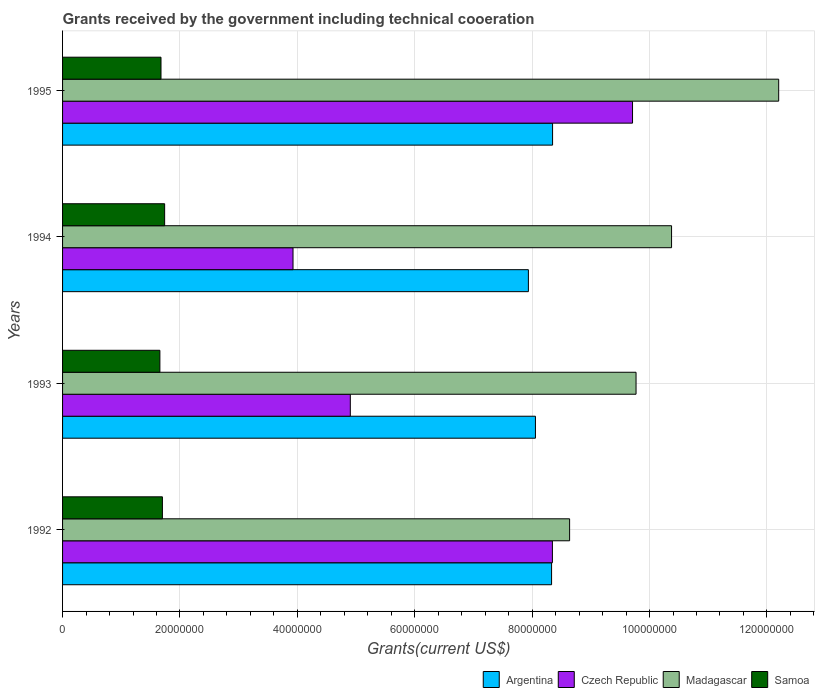How many different coloured bars are there?
Make the answer very short. 4. What is the total grants received by the government in Argentina in 1992?
Your answer should be very brief. 8.33e+07. Across all years, what is the maximum total grants received by the government in Samoa?
Provide a short and direct response. 1.74e+07. Across all years, what is the minimum total grants received by the government in Czech Republic?
Your answer should be compact. 3.93e+07. In which year was the total grants received by the government in Argentina maximum?
Keep it short and to the point. 1995. In which year was the total grants received by the government in Argentina minimum?
Offer a very short reply. 1994. What is the total total grants received by the government in Czech Republic in the graph?
Your answer should be very brief. 2.69e+08. What is the difference between the total grants received by the government in Czech Republic in 1994 and that in 1995?
Give a very brief answer. -5.78e+07. What is the difference between the total grants received by the government in Madagascar in 1993 and the total grants received by the government in Argentina in 1995?
Your answer should be compact. 1.42e+07. What is the average total grants received by the government in Czech Republic per year?
Provide a succinct answer. 6.72e+07. In the year 1993, what is the difference between the total grants received by the government in Czech Republic and total grants received by the government in Samoa?
Your answer should be very brief. 3.24e+07. In how many years, is the total grants received by the government in Argentina greater than 12000000 US$?
Your response must be concise. 4. What is the ratio of the total grants received by the government in Madagascar in 1993 to that in 1995?
Give a very brief answer. 0.8. Is the total grants received by the government in Argentina in 1994 less than that in 1995?
Provide a succinct answer. Yes. What is the difference between the highest and the second highest total grants received by the government in Czech Republic?
Offer a very short reply. 1.36e+07. What is the difference between the highest and the lowest total grants received by the government in Samoa?
Provide a succinct answer. 8.10e+05. What does the 1st bar from the top in 1995 represents?
Make the answer very short. Samoa. What does the 1st bar from the bottom in 1993 represents?
Your response must be concise. Argentina. Is it the case that in every year, the sum of the total grants received by the government in Madagascar and total grants received by the government in Czech Republic is greater than the total grants received by the government in Samoa?
Provide a succinct answer. Yes. How many bars are there?
Provide a short and direct response. 16. How many years are there in the graph?
Your answer should be compact. 4. What is the difference between two consecutive major ticks on the X-axis?
Offer a very short reply. 2.00e+07. How are the legend labels stacked?
Offer a very short reply. Horizontal. What is the title of the graph?
Offer a terse response. Grants received by the government including technical cooeration. What is the label or title of the X-axis?
Offer a terse response. Grants(current US$). What is the label or title of the Y-axis?
Keep it short and to the point. Years. What is the Grants(current US$) in Argentina in 1992?
Offer a terse response. 8.33e+07. What is the Grants(current US$) of Czech Republic in 1992?
Ensure brevity in your answer.  8.34e+07. What is the Grants(current US$) of Madagascar in 1992?
Offer a very short reply. 8.64e+07. What is the Grants(current US$) of Samoa in 1992?
Keep it short and to the point. 1.70e+07. What is the Grants(current US$) of Argentina in 1993?
Offer a very short reply. 8.06e+07. What is the Grants(current US$) of Czech Republic in 1993?
Your answer should be very brief. 4.90e+07. What is the Grants(current US$) of Madagascar in 1993?
Ensure brevity in your answer.  9.77e+07. What is the Grants(current US$) in Samoa in 1993?
Your response must be concise. 1.66e+07. What is the Grants(current US$) of Argentina in 1994?
Give a very brief answer. 7.94e+07. What is the Grants(current US$) of Czech Republic in 1994?
Your response must be concise. 3.93e+07. What is the Grants(current US$) of Madagascar in 1994?
Ensure brevity in your answer.  1.04e+08. What is the Grants(current US$) of Samoa in 1994?
Ensure brevity in your answer.  1.74e+07. What is the Grants(current US$) of Argentina in 1995?
Offer a very short reply. 8.35e+07. What is the Grants(current US$) of Czech Republic in 1995?
Make the answer very short. 9.71e+07. What is the Grants(current US$) in Madagascar in 1995?
Keep it short and to the point. 1.22e+08. What is the Grants(current US$) of Samoa in 1995?
Ensure brevity in your answer.  1.68e+07. Across all years, what is the maximum Grants(current US$) in Argentina?
Offer a very short reply. 8.35e+07. Across all years, what is the maximum Grants(current US$) in Czech Republic?
Your response must be concise. 9.71e+07. Across all years, what is the maximum Grants(current US$) of Madagascar?
Your response must be concise. 1.22e+08. Across all years, what is the maximum Grants(current US$) in Samoa?
Ensure brevity in your answer.  1.74e+07. Across all years, what is the minimum Grants(current US$) in Argentina?
Ensure brevity in your answer.  7.94e+07. Across all years, what is the minimum Grants(current US$) in Czech Republic?
Offer a very short reply. 3.93e+07. Across all years, what is the minimum Grants(current US$) in Madagascar?
Offer a very short reply. 8.64e+07. Across all years, what is the minimum Grants(current US$) of Samoa?
Keep it short and to the point. 1.66e+07. What is the total Grants(current US$) in Argentina in the graph?
Your answer should be very brief. 3.27e+08. What is the total Grants(current US$) of Czech Republic in the graph?
Your answer should be compact. 2.69e+08. What is the total Grants(current US$) in Madagascar in the graph?
Offer a terse response. 4.10e+08. What is the total Grants(current US$) of Samoa in the graph?
Offer a very short reply. 6.78e+07. What is the difference between the Grants(current US$) of Argentina in 1992 and that in 1993?
Give a very brief answer. 2.75e+06. What is the difference between the Grants(current US$) of Czech Republic in 1992 and that in 1993?
Ensure brevity in your answer.  3.44e+07. What is the difference between the Grants(current US$) in Madagascar in 1992 and that in 1993?
Ensure brevity in your answer.  -1.13e+07. What is the difference between the Grants(current US$) in Argentina in 1992 and that in 1994?
Ensure brevity in your answer.  3.95e+06. What is the difference between the Grants(current US$) of Czech Republic in 1992 and that in 1994?
Ensure brevity in your answer.  4.42e+07. What is the difference between the Grants(current US$) of Madagascar in 1992 and that in 1994?
Provide a succinct answer. -1.74e+07. What is the difference between the Grants(current US$) of Samoa in 1992 and that in 1994?
Offer a very short reply. -3.80e+05. What is the difference between the Grants(current US$) of Czech Republic in 1992 and that in 1995?
Provide a succinct answer. -1.36e+07. What is the difference between the Grants(current US$) in Madagascar in 1992 and that in 1995?
Your response must be concise. -3.56e+07. What is the difference between the Grants(current US$) of Samoa in 1992 and that in 1995?
Offer a very short reply. 2.40e+05. What is the difference between the Grants(current US$) in Argentina in 1993 and that in 1994?
Make the answer very short. 1.20e+06. What is the difference between the Grants(current US$) of Czech Republic in 1993 and that in 1994?
Make the answer very short. 9.76e+06. What is the difference between the Grants(current US$) of Madagascar in 1993 and that in 1994?
Ensure brevity in your answer.  -6.05e+06. What is the difference between the Grants(current US$) of Samoa in 1993 and that in 1994?
Your response must be concise. -8.10e+05. What is the difference between the Grants(current US$) in Argentina in 1993 and that in 1995?
Give a very brief answer. -2.92e+06. What is the difference between the Grants(current US$) in Czech Republic in 1993 and that in 1995?
Offer a very short reply. -4.81e+07. What is the difference between the Grants(current US$) of Madagascar in 1993 and that in 1995?
Provide a short and direct response. -2.43e+07. What is the difference between the Grants(current US$) of Argentina in 1994 and that in 1995?
Your response must be concise. -4.12e+06. What is the difference between the Grants(current US$) in Czech Republic in 1994 and that in 1995?
Offer a very short reply. -5.78e+07. What is the difference between the Grants(current US$) of Madagascar in 1994 and that in 1995?
Keep it short and to the point. -1.82e+07. What is the difference between the Grants(current US$) of Samoa in 1994 and that in 1995?
Keep it short and to the point. 6.20e+05. What is the difference between the Grants(current US$) in Argentina in 1992 and the Grants(current US$) in Czech Republic in 1993?
Keep it short and to the point. 3.43e+07. What is the difference between the Grants(current US$) of Argentina in 1992 and the Grants(current US$) of Madagascar in 1993?
Offer a terse response. -1.44e+07. What is the difference between the Grants(current US$) in Argentina in 1992 and the Grants(current US$) in Samoa in 1993?
Your answer should be very brief. 6.67e+07. What is the difference between the Grants(current US$) in Czech Republic in 1992 and the Grants(current US$) in Madagascar in 1993?
Provide a short and direct response. -1.42e+07. What is the difference between the Grants(current US$) of Czech Republic in 1992 and the Grants(current US$) of Samoa in 1993?
Provide a succinct answer. 6.69e+07. What is the difference between the Grants(current US$) in Madagascar in 1992 and the Grants(current US$) in Samoa in 1993?
Offer a terse response. 6.98e+07. What is the difference between the Grants(current US$) in Argentina in 1992 and the Grants(current US$) in Czech Republic in 1994?
Provide a short and direct response. 4.40e+07. What is the difference between the Grants(current US$) of Argentina in 1992 and the Grants(current US$) of Madagascar in 1994?
Offer a terse response. -2.04e+07. What is the difference between the Grants(current US$) in Argentina in 1992 and the Grants(current US$) in Samoa in 1994?
Keep it short and to the point. 6.59e+07. What is the difference between the Grants(current US$) in Czech Republic in 1992 and the Grants(current US$) in Madagascar in 1994?
Provide a short and direct response. -2.03e+07. What is the difference between the Grants(current US$) of Czech Republic in 1992 and the Grants(current US$) of Samoa in 1994?
Provide a succinct answer. 6.61e+07. What is the difference between the Grants(current US$) in Madagascar in 1992 and the Grants(current US$) in Samoa in 1994?
Your response must be concise. 6.90e+07. What is the difference between the Grants(current US$) in Argentina in 1992 and the Grants(current US$) in Czech Republic in 1995?
Provide a succinct answer. -1.38e+07. What is the difference between the Grants(current US$) in Argentina in 1992 and the Grants(current US$) in Madagascar in 1995?
Make the answer very short. -3.87e+07. What is the difference between the Grants(current US$) of Argentina in 1992 and the Grants(current US$) of Samoa in 1995?
Your response must be concise. 6.65e+07. What is the difference between the Grants(current US$) in Czech Republic in 1992 and the Grants(current US$) in Madagascar in 1995?
Your answer should be very brief. -3.86e+07. What is the difference between the Grants(current US$) of Czech Republic in 1992 and the Grants(current US$) of Samoa in 1995?
Give a very brief answer. 6.67e+07. What is the difference between the Grants(current US$) in Madagascar in 1992 and the Grants(current US$) in Samoa in 1995?
Your answer should be compact. 6.96e+07. What is the difference between the Grants(current US$) of Argentina in 1993 and the Grants(current US$) of Czech Republic in 1994?
Provide a succinct answer. 4.13e+07. What is the difference between the Grants(current US$) of Argentina in 1993 and the Grants(current US$) of Madagascar in 1994?
Offer a terse response. -2.32e+07. What is the difference between the Grants(current US$) of Argentina in 1993 and the Grants(current US$) of Samoa in 1994?
Your answer should be compact. 6.32e+07. What is the difference between the Grants(current US$) in Czech Republic in 1993 and the Grants(current US$) in Madagascar in 1994?
Your response must be concise. -5.47e+07. What is the difference between the Grants(current US$) in Czech Republic in 1993 and the Grants(current US$) in Samoa in 1994?
Your answer should be compact. 3.16e+07. What is the difference between the Grants(current US$) of Madagascar in 1993 and the Grants(current US$) of Samoa in 1994?
Offer a terse response. 8.03e+07. What is the difference between the Grants(current US$) of Argentina in 1993 and the Grants(current US$) of Czech Republic in 1995?
Your answer should be compact. -1.65e+07. What is the difference between the Grants(current US$) of Argentina in 1993 and the Grants(current US$) of Madagascar in 1995?
Keep it short and to the point. -4.14e+07. What is the difference between the Grants(current US$) of Argentina in 1993 and the Grants(current US$) of Samoa in 1995?
Give a very brief answer. 6.38e+07. What is the difference between the Grants(current US$) of Czech Republic in 1993 and the Grants(current US$) of Madagascar in 1995?
Your answer should be very brief. -7.30e+07. What is the difference between the Grants(current US$) of Czech Republic in 1993 and the Grants(current US$) of Samoa in 1995?
Offer a terse response. 3.22e+07. What is the difference between the Grants(current US$) in Madagascar in 1993 and the Grants(current US$) in Samoa in 1995?
Offer a terse response. 8.09e+07. What is the difference between the Grants(current US$) of Argentina in 1994 and the Grants(current US$) of Czech Republic in 1995?
Your response must be concise. -1.77e+07. What is the difference between the Grants(current US$) in Argentina in 1994 and the Grants(current US$) in Madagascar in 1995?
Offer a terse response. -4.26e+07. What is the difference between the Grants(current US$) of Argentina in 1994 and the Grants(current US$) of Samoa in 1995?
Your response must be concise. 6.26e+07. What is the difference between the Grants(current US$) in Czech Republic in 1994 and the Grants(current US$) in Madagascar in 1995?
Provide a succinct answer. -8.27e+07. What is the difference between the Grants(current US$) of Czech Republic in 1994 and the Grants(current US$) of Samoa in 1995?
Offer a very short reply. 2.25e+07. What is the difference between the Grants(current US$) in Madagascar in 1994 and the Grants(current US$) in Samoa in 1995?
Make the answer very short. 8.70e+07. What is the average Grants(current US$) of Argentina per year?
Give a very brief answer. 8.17e+07. What is the average Grants(current US$) in Czech Republic per year?
Keep it short and to the point. 6.72e+07. What is the average Grants(current US$) in Madagascar per year?
Keep it short and to the point. 1.02e+08. What is the average Grants(current US$) of Samoa per year?
Your answer should be very brief. 1.69e+07. In the year 1992, what is the difference between the Grants(current US$) of Argentina and Grants(current US$) of Czech Republic?
Your answer should be compact. -1.40e+05. In the year 1992, what is the difference between the Grants(current US$) in Argentina and Grants(current US$) in Madagascar?
Provide a succinct answer. -3.07e+06. In the year 1992, what is the difference between the Grants(current US$) of Argentina and Grants(current US$) of Samoa?
Provide a short and direct response. 6.63e+07. In the year 1992, what is the difference between the Grants(current US$) in Czech Republic and Grants(current US$) in Madagascar?
Your answer should be very brief. -2.93e+06. In the year 1992, what is the difference between the Grants(current US$) in Czech Republic and Grants(current US$) in Samoa?
Provide a short and direct response. 6.64e+07. In the year 1992, what is the difference between the Grants(current US$) of Madagascar and Grants(current US$) of Samoa?
Give a very brief answer. 6.94e+07. In the year 1993, what is the difference between the Grants(current US$) in Argentina and Grants(current US$) in Czech Republic?
Make the answer very short. 3.15e+07. In the year 1993, what is the difference between the Grants(current US$) in Argentina and Grants(current US$) in Madagascar?
Ensure brevity in your answer.  -1.71e+07. In the year 1993, what is the difference between the Grants(current US$) in Argentina and Grants(current US$) in Samoa?
Make the answer very short. 6.40e+07. In the year 1993, what is the difference between the Grants(current US$) in Czech Republic and Grants(current US$) in Madagascar?
Provide a short and direct response. -4.87e+07. In the year 1993, what is the difference between the Grants(current US$) of Czech Republic and Grants(current US$) of Samoa?
Your answer should be very brief. 3.24e+07. In the year 1993, what is the difference between the Grants(current US$) of Madagascar and Grants(current US$) of Samoa?
Offer a terse response. 8.11e+07. In the year 1994, what is the difference between the Grants(current US$) in Argentina and Grants(current US$) in Czech Republic?
Keep it short and to the point. 4.01e+07. In the year 1994, what is the difference between the Grants(current US$) of Argentina and Grants(current US$) of Madagascar?
Your answer should be very brief. -2.44e+07. In the year 1994, what is the difference between the Grants(current US$) of Argentina and Grants(current US$) of Samoa?
Your response must be concise. 6.20e+07. In the year 1994, what is the difference between the Grants(current US$) of Czech Republic and Grants(current US$) of Madagascar?
Offer a terse response. -6.45e+07. In the year 1994, what is the difference between the Grants(current US$) of Czech Republic and Grants(current US$) of Samoa?
Ensure brevity in your answer.  2.19e+07. In the year 1994, what is the difference between the Grants(current US$) of Madagascar and Grants(current US$) of Samoa?
Make the answer very short. 8.64e+07. In the year 1995, what is the difference between the Grants(current US$) in Argentina and Grants(current US$) in Czech Republic?
Your answer should be compact. -1.36e+07. In the year 1995, what is the difference between the Grants(current US$) in Argentina and Grants(current US$) in Madagascar?
Give a very brief answer. -3.85e+07. In the year 1995, what is the difference between the Grants(current US$) in Argentina and Grants(current US$) in Samoa?
Your response must be concise. 6.67e+07. In the year 1995, what is the difference between the Grants(current US$) in Czech Republic and Grants(current US$) in Madagascar?
Keep it short and to the point. -2.49e+07. In the year 1995, what is the difference between the Grants(current US$) in Czech Republic and Grants(current US$) in Samoa?
Provide a succinct answer. 8.03e+07. In the year 1995, what is the difference between the Grants(current US$) of Madagascar and Grants(current US$) of Samoa?
Your answer should be compact. 1.05e+08. What is the ratio of the Grants(current US$) in Argentina in 1992 to that in 1993?
Provide a short and direct response. 1.03. What is the ratio of the Grants(current US$) in Czech Republic in 1992 to that in 1993?
Offer a very short reply. 1.7. What is the ratio of the Grants(current US$) in Madagascar in 1992 to that in 1993?
Your answer should be very brief. 0.88. What is the ratio of the Grants(current US$) in Samoa in 1992 to that in 1993?
Make the answer very short. 1.03. What is the ratio of the Grants(current US$) of Argentina in 1992 to that in 1994?
Ensure brevity in your answer.  1.05. What is the ratio of the Grants(current US$) of Czech Republic in 1992 to that in 1994?
Offer a terse response. 2.13. What is the ratio of the Grants(current US$) in Madagascar in 1992 to that in 1994?
Give a very brief answer. 0.83. What is the ratio of the Grants(current US$) in Samoa in 1992 to that in 1994?
Offer a terse response. 0.98. What is the ratio of the Grants(current US$) in Argentina in 1992 to that in 1995?
Your response must be concise. 1. What is the ratio of the Grants(current US$) of Czech Republic in 1992 to that in 1995?
Offer a very short reply. 0.86. What is the ratio of the Grants(current US$) of Madagascar in 1992 to that in 1995?
Give a very brief answer. 0.71. What is the ratio of the Grants(current US$) of Samoa in 1992 to that in 1995?
Your answer should be very brief. 1.01. What is the ratio of the Grants(current US$) of Argentina in 1993 to that in 1994?
Your answer should be compact. 1.02. What is the ratio of the Grants(current US$) in Czech Republic in 1993 to that in 1994?
Give a very brief answer. 1.25. What is the ratio of the Grants(current US$) of Madagascar in 1993 to that in 1994?
Give a very brief answer. 0.94. What is the ratio of the Grants(current US$) in Samoa in 1993 to that in 1994?
Your response must be concise. 0.95. What is the ratio of the Grants(current US$) in Argentina in 1993 to that in 1995?
Provide a succinct answer. 0.96. What is the ratio of the Grants(current US$) in Czech Republic in 1993 to that in 1995?
Provide a succinct answer. 0.5. What is the ratio of the Grants(current US$) in Madagascar in 1993 to that in 1995?
Offer a very short reply. 0.8. What is the ratio of the Grants(current US$) of Samoa in 1993 to that in 1995?
Offer a terse response. 0.99. What is the ratio of the Grants(current US$) of Argentina in 1994 to that in 1995?
Offer a terse response. 0.95. What is the ratio of the Grants(current US$) of Czech Republic in 1994 to that in 1995?
Give a very brief answer. 0.4. What is the ratio of the Grants(current US$) in Madagascar in 1994 to that in 1995?
Offer a very short reply. 0.85. What is the ratio of the Grants(current US$) of Samoa in 1994 to that in 1995?
Provide a short and direct response. 1.04. What is the difference between the highest and the second highest Grants(current US$) in Argentina?
Offer a very short reply. 1.70e+05. What is the difference between the highest and the second highest Grants(current US$) of Czech Republic?
Make the answer very short. 1.36e+07. What is the difference between the highest and the second highest Grants(current US$) of Madagascar?
Your response must be concise. 1.82e+07. What is the difference between the highest and the lowest Grants(current US$) of Argentina?
Offer a terse response. 4.12e+06. What is the difference between the highest and the lowest Grants(current US$) of Czech Republic?
Give a very brief answer. 5.78e+07. What is the difference between the highest and the lowest Grants(current US$) of Madagascar?
Offer a terse response. 3.56e+07. What is the difference between the highest and the lowest Grants(current US$) of Samoa?
Provide a succinct answer. 8.10e+05. 